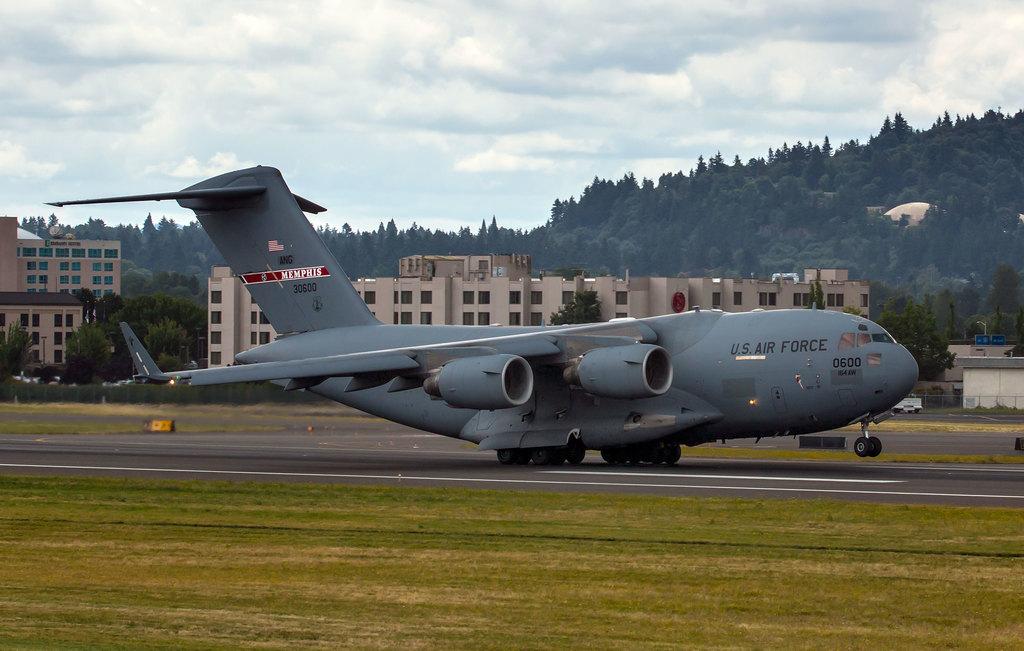What city name is mentioned on the tail of the plane?
Your response must be concise. Memphis. Which airbase is this?
Provide a succinct answer. Unanswerable. 